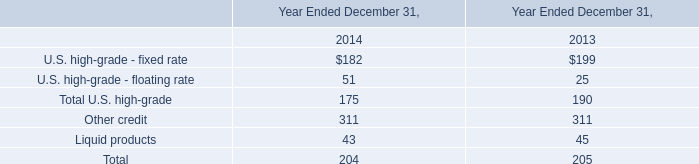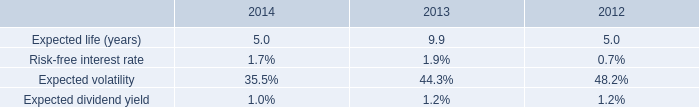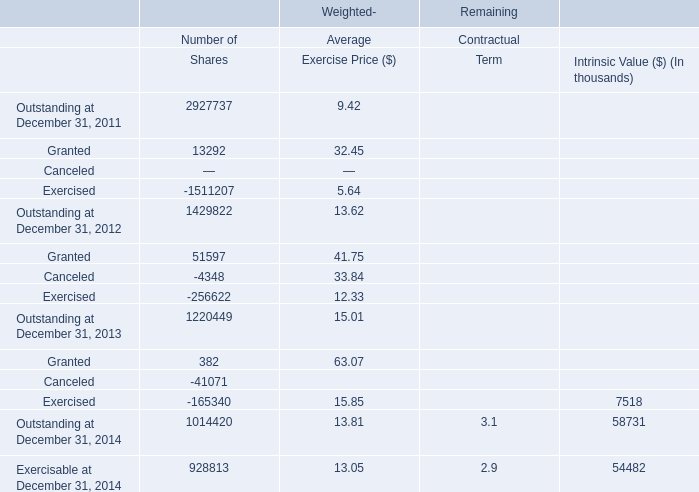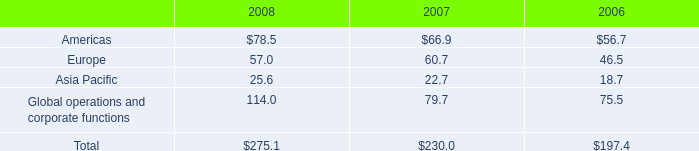what percent does total depreciation & amortization expenses increase between 2006 and 2008? 
Computations: ((275.1 / 197.4) - 1)
Answer: 0.39362. 